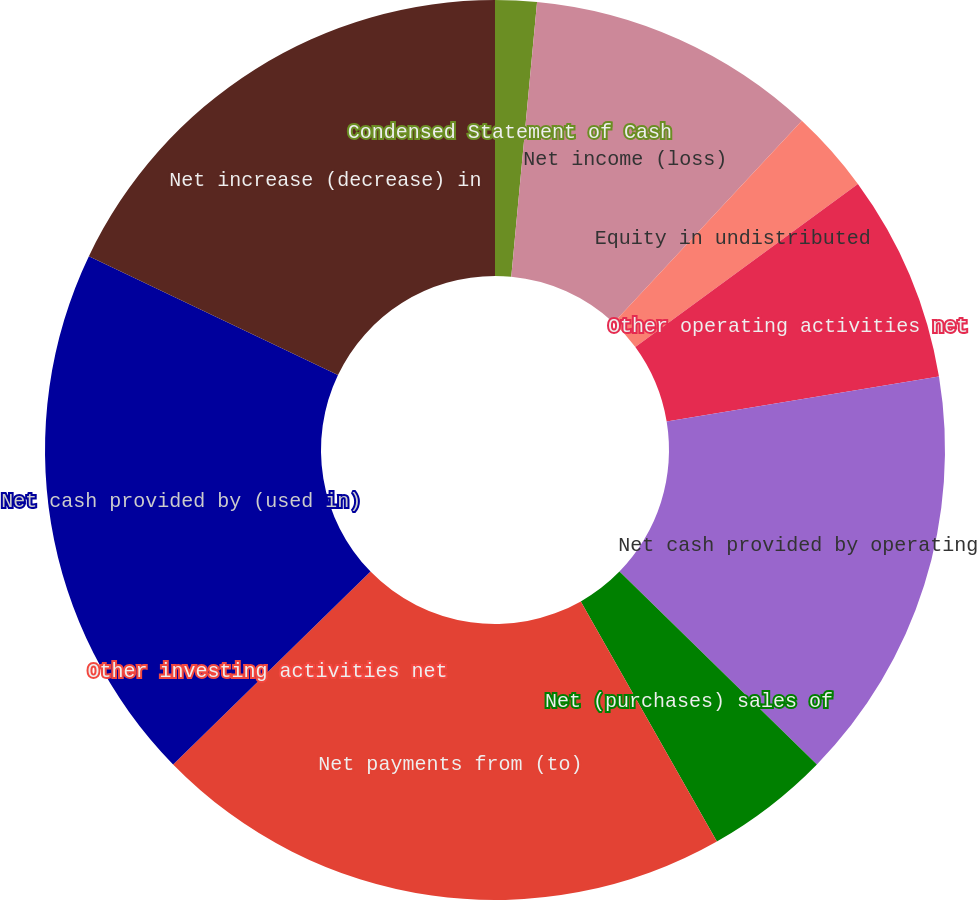Convert chart to OTSL. <chart><loc_0><loc_0><loc_500><loc_500><pie_chart><fcel>Condensed Statement of Cash<fcel>Net income (loss)<fcel>Equity in undistributed<fcel>Other operating activities net<fcel>Net cash provided by operating<fcel>Net (purchases) sales of<fcel>Net payments from (to)<fcel>Other investing activities net<fcel>Net cash provided by (used in)<fcel>Net increase (decrease) in<nl><fcel>1.49%<fcel>10.45%<fcel>2.99%<fcel>7.46%<fcel>14.92%<fcel>4.48%<fcel>20.89%<fcel>0.0%<fcel>19.4%<fcel>17.91%<nl></chart> 